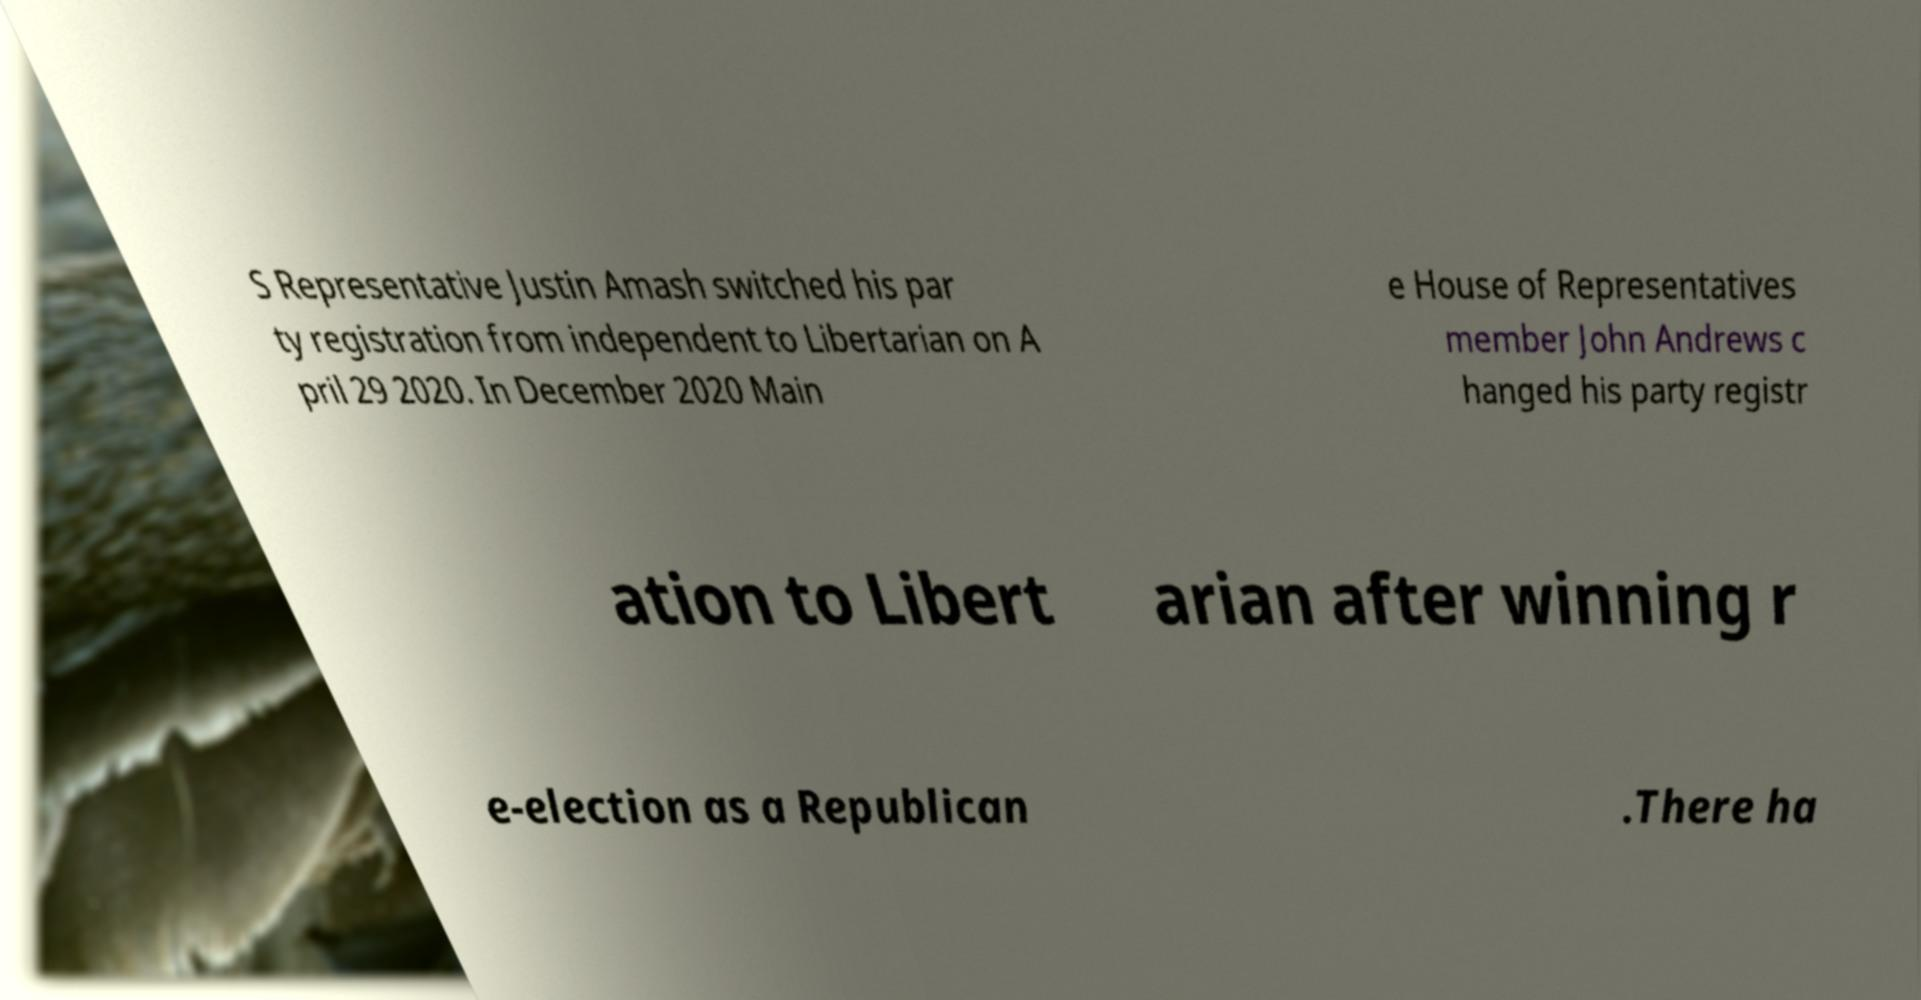There's text embedded in this image that I need extracted. Can you transcribe it verbatim? S Representative Justin Amash switched his par ty registration from independent to Libertarian on A pril 29 2020. In December 2020 Main e House of Representatives member John Andrews c hanged his party registr ation to Libert arian after winning r e-election as a Republican .There ha 